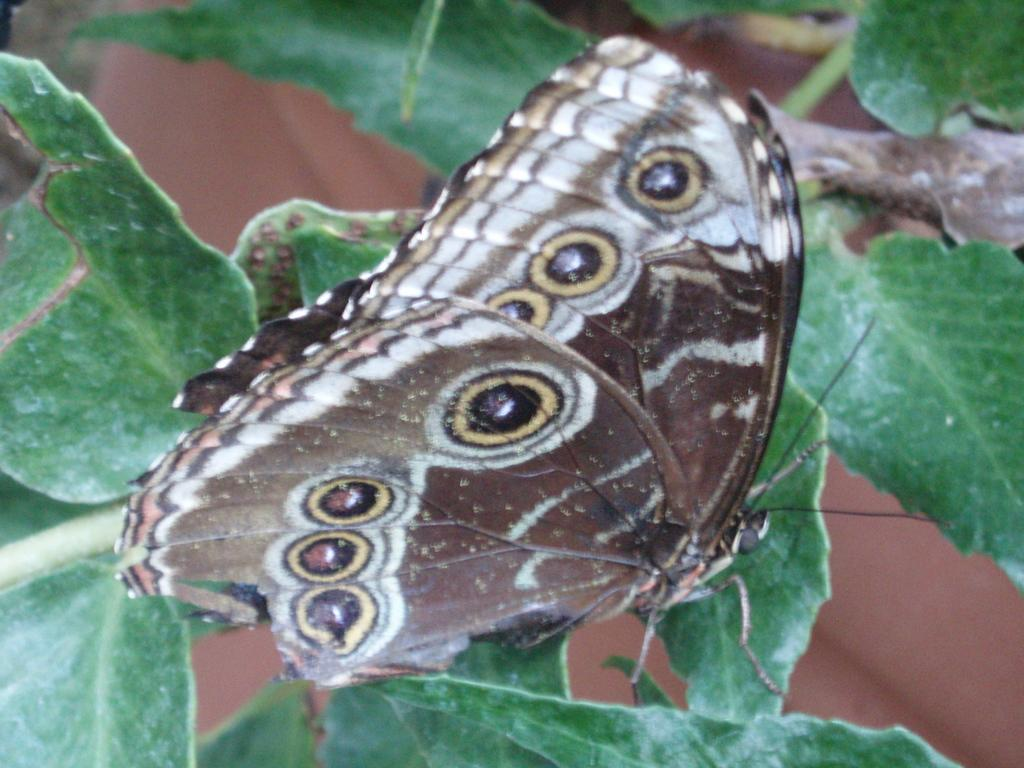What is the main subject in the foreground of the image? There is a butterfly on a leaf in the foreground of the image. What else can be seen in the image besides the butterfly? Leaves are visible in the image. Can you tell me how many times the grandfather swims under the faucet in the image? There is no grandfather or faucet present in the image; it features a butterfly on a leaf and leaves. 